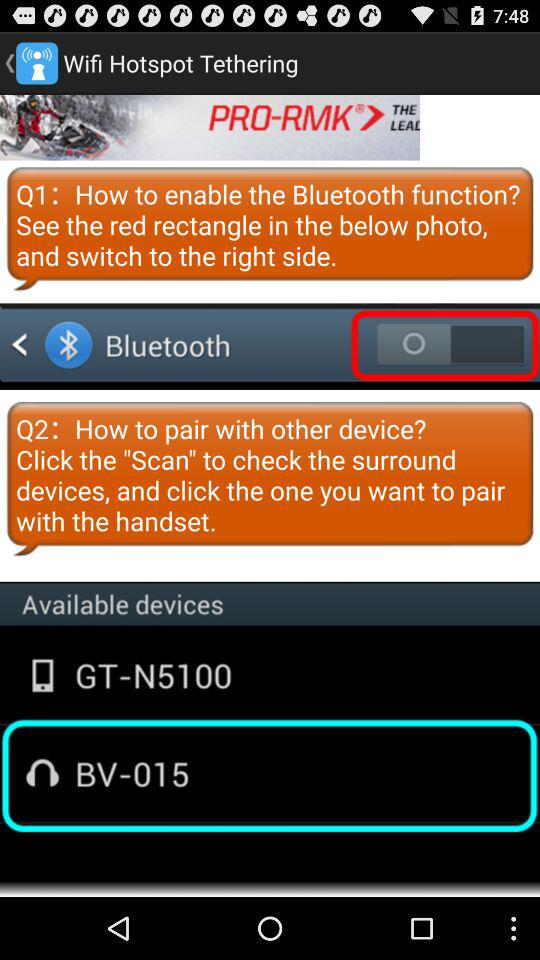What is the status of Bluetooth? The status is "off". 